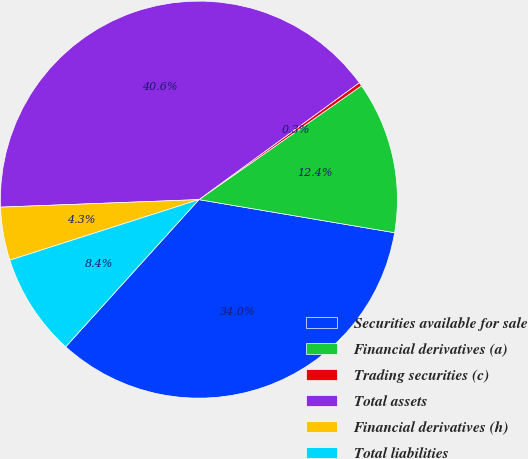Convert chart. <chart><loc_0><loc_0><loc_500><loc_500><pie_chart><fcel>Securities available for sale<fcel>Financial derivatives (a)<fcel>Trading securities (c)<fcel>Total assets<fcel>Financial derivatives (h)<fcel>Total liabilities<nl><fcel>34.04%<fcel>12.39%<fcel>0.3%<fcel>40.58%<fcel>4.33%<fcel>8.36%<nl></chart> 